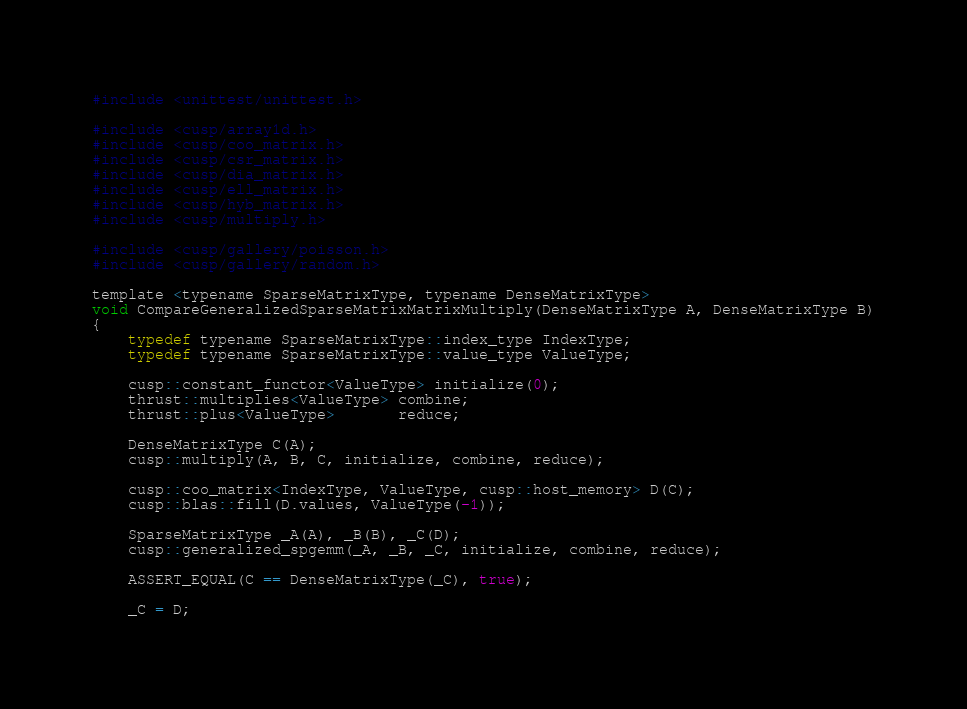Convert code to text. <code><loc_0><loc_0><loc_500><loc_500><_Cuda_>#include <unittest/unittest.h>

#include <cusp/array1d.h>
#include <cusp/coo_matrix.h>
#include <cusp/csr_matrix.h>
#include <cusp/dia_matrix.h>
#include <cusp/ell_matrix.h>
#include <cusp/hyb_matrix.h>
#include <cusp/multiply.h>

#include <cusp/gallery/poisson.h>
#include <cusp/gallery/random.h>

template <typename SparseMatrixType, typename DenseMatrixType>
void CompareGeneralizedSparseMatrixMatrixMultiply(DenseMatrixType A, DenseMatrixType B)
{
    typedef typename SparseMatrixType::index_type IndexType;
    typedef typename SparseMatrixType::value_type ValueType;

    cusp::constant_functor<ValueType> initialize(0);
    thrust::multiplies<ValueType> combine;
    thrust::plus<ValueType>       reduce;

    DenseMatrixType C(A);
    cusp::multiply(A, B, C, initialize, combine, reduce);

    cusp::coo_matrix<IndexType, ValueType, cusp::host_memory> D(C);
    cusp::blas::fill(D.values, ValueType(-1));

    SparseMatrixType _A(A), _B(B), _C(D);
    cusp::generalized_spgemm(_A, _B, _C, initialize, combine, reduce);

    ASSERT_EQUAL(C == DenseMatrixType(_C), true);

    _C = D;</code> 